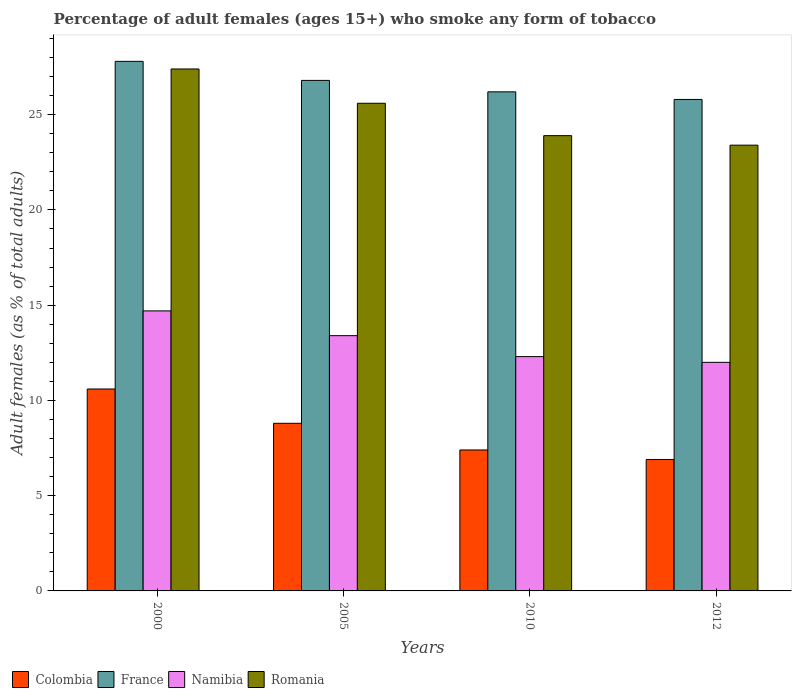How many groups of bars are there?
Offer a terse response. 4. What is the label of the 1st group of bars from the left?
Give a very brief answer. 2000. In how many cases, is the number of bars for a given year not equal to the number of legend labels?
Ensure brevity in your answer.  0. What is the percentage of adult females who smoke in France in 2012?
Provide a succinct answer. 25.8. Across all years, what is the maximum percentage of adult females who smoke in France?
Your answer should be compact. 27.8. Across all years, what is the minimum percentage of adult females who smoke in Romania?
Offer a very short reply. 23.4. In which year was the percentage of adult females who smoke in France minimum?
Your response must be concise. 2012. What is the total percentage of adult females who smoke in Colombia in the graph?
Provide a succinct answer. 33.7. What is the difference between the percentage of adult females who smoke in Namibia in 2000 and that in 2012?
Provide a short and direct response. 2.7. What is the difference between the percentage of adult females who smoke in Namibia in 2010 and the percentage of adult females who smoke in France in 2012?
Provide a short and direct response. -13.5. What is the average percentage of adult females who smoke in France per year?
Offer a very short reply. 26.65. In the year 2000, what is the difference between the percentage of adult females who smoke in France and percentage of adult females who smoke in Romania?
Provide a succinct answer. 0.4. What is the ratio of the percentage of adult females who smoke in Romania in 2005 to that in 2012?
Keep it short and to the point. 1.09. What is the difference between the highest and the second highest percentage of adult females who smoke in Romania?
Make the answer very short. 1.8. What is the difference between the highest and the lowest percentage of adult females who smoke in Romania?
Make the answer very short. 4. Is the sum of the percentage of adult females who smoke in Colombia in 2005 and 2010 greater than the maximum percentage of adult females who smoke in Romania across all years?
Ensure brevity in your answer.  No. What does the 4th bar from the left in 2000 represents?
Provide a succinct answer. Romania. Is it the case that in every year, the sum of the percentage of adult females who smoke in Romania and percentage of adult females who smoke in Namibia is greater than the percentage of adult females who smoke in France?
Offer a terse response. Yes. How many bars are there?
Give a very brief answer. 16. How many years are there in the graph?
Your answer should be very brief. 4. What is the difference between two consecutive major ticks on the Y-axis?
Provide a short and direct response. 5. Are the values on the major ticks of Y-axis written in scientific E-notation?
Provide a succinct answer. No. How many legend labels are there?
Provide a succinct answer. 4. What is the title of the graph?
Keep it short and to the point. Percentage of adult females (ages 15+) who smoke any form of tobacco. What is the label or title of the Y-axis?
Provide a succinct answer. Adult females (as % of total adults). What is the Adult females (as % of total adults) of France in 2000?
Give a very brief answer. 27.8. What is the Adult females (as % of total adults) of Romania in 2000?
Your response must be concise. 27.4. What is the Adult females (as % of total adults) of France in 2005?
Keep it short and to the point. 26.8. What is the Adult females (as % of total adults) of Romania in 2005?
Your answer should be very brief. 25.6. What is the Adult females (as % of total adults) of Colombia in 2010?
Your answer should be very brief. 7.4. What is the Adult females (as % of total adults) in France in 2010?
Your answer should be compact. 26.2. What is the Adult females (as % of total adults) in Namibia in 2010?
Give a very brief answer. 12.3. What is the Adult females (as % of total adults) in Romania in 2010?
Provide a succinct answer. 23.9. What is the Adult females (as % of total adults) of Colombia in 2012?
Your answer should be very brief. 6.9. What is the Adult females (as % of total adults) in France in 2012?
Your answer should be very brief. 25.8. What is the Adult females (as % of total adults) in Romania in 2012?
Offer a terse response. 23.4. Across all years, what is the maximum Adult females (as % of total adults) in France?
Offer a very short reply. 27.8. Across all years, what is the maximum Adult females (as % of total adults) of Namibia?
Your answer should be compact. 14.7. Across all years, what is the maximum Adult females (as % of total adults) of Romania?
Your answer should be compact. 27.4. Across all years, what is the minimum Adult females (as % of total adults) in Colombia?
Provide a short and direct response. 6.9. Across all years, what is the minimum Adult females (as % of total adults) of France?
Give a very brief answer. 25.8. Across all years, what is the minimum Adult females (as % of total adults) of Namibia?
Give a very brief answer. 12. Across all years, what is the minimum Adult females (as % of total adults) in Romania?
Keep it short and to the point. 23.4. What is the total Adult females (as % of total adults) in Colombia in the graph?
Provide a short and direct response. 33.7. What is the total Adult females (as % of total adults) in France in the graph?
Your response must be concise. 106.6. What is the total Adult females (as % of total adults) of Namibia in the graph?
Your answer should be very brief. 52.4. What is the total Adult females (as % of total adults) in Romania in the graph?
Give a very brief answer. 100.3. What is the difference between the Adult females (as % of total adults) of Colombia in 2000 and that in 2005?
Ensure brevity in your answer.  1.8. What is the difference between the Adult females (as % of total adults) of France in 2000 and that in 2005?
Your answer should be very brief. 1. What is the difference between the Adult females (as % of total adults) of Colombia in 2000 and that in 2010?
Make the answer very short. 3.2. What is the difference between the Adult females (as % of total adults) of Namibia in 2000 and that in 2010?
Ensure brevity in your answer.  2.4. What is the difference between the Adult females (as % of total adults) of Romania in 2000 and that in 2012?
Give a very brief answer. 4. What is the difference between the Adult females (as % of total adults) of Colombia in 2005 and that in 2010?
Make the answer very short. 1.4. What is the difference between the Adult females (as % of total adults) of France in 2005 and that in 2010?
Ensure brevity in your answer.  0.6. What is the difference between the Adult females (as % of total adults) of Namibia in 2005 and that in 2010?
Ensure brevity in your answer.  1.1. What is the difference between the Adult females (as % of total adults) of Romania in 2005 and that in 2010?
Offer a very short reply. 1.7. What is the difference between the Adult females (as % of total adults) in Namibia in 2005 and that in 2012?
Your answer should be very brief. 1.4. What is the difference between the Adult females (as % of total adults) of France in 2010 and that in 2012?
Make the answer very short. 0.4. What is the difference between the Adult females (as % of total adults) in Romania in 2010 and that in 2012?
Make the answer very short. 0.5. What is the difference between the Adult females (as % of total adults) of Colombia in 2000 and the Adult females (as % of total adults) of France in 2005?
Give a very brief answer. -16.2. What is the difference between the Adult females (as % of total adults) in Colombia in 2000 and the Adult females (as % of total adults) in Namibia in 2005?
Keep it short and to the point. -2.8. What is the difference between the Adult females (as % of total adults) of Colombia in 2000 and the Adult females (as % of total adults) of Romania in 2005?
Ensure brevity in your answer.  -15. What is the difference between the Adult females (as % of total adults) of France in 2000 and the Adult females (as % of total adults) of Namibia in 2005?
Your answer should be compact. 14.4. What is the difference between the Adult females (as % of total adults) of France in 2000 and the Adult females (as % of total adults) of Romania in 2005?
Provide a succinct answer. 2.2. What is the difference between the Adult females (as % of total adults) of Colombia in 2000 and the Adult females (as % of total adults) of France in 2010?
Ensure brevity in your answer.  -15.6. What is the difference between the Adult females (as % of total adults) in Colombia in 2000 and the Adult females (as % of total adults) in Romania in 2010?
Ensure brevity in your answer.  -13.3. What is the difference between the Adult females (as % of total adults) in France in 2000 and the Adult females (as % of total adults) in Romania in 2010?
Your answer should be compact. 3.9. What is the difference between the Adult females (as % of total adults) in Namibia in 2000 and the Adult females (as % of total adults) in Romania in 2010?
Offer a very short reply. -9.2. What is the difference between the Adult females (as % of total adults) in Colombia in 2000 and the Adult females (as % of total adults) in France in 2012?
Your response must be concise. -15.2. What is the difference between the Adult females (as % of total adults) of Colombia in 2000 and the Adult females (as % of total adults) of Romania in 2012?
Offer a terse response. -12.8. What is the difference between the Adult females (as % of total adults) of Namibia in 2000 and the Adult females (as % of total adults) of Romania in 2012?
Your answer should be very brief. -8.7. What is the difference between the Adult females (as % of total adults) of Colombia in 2005 and the Adult females (as % of total adults) of France in 2010?
Your response must be concise. -17.4. What is the difference between the Adult females (as % of total adults) in Colombia in 2005 and the Adult females (as % of total adults) in Romania in 2010?
Offer a terse response. -15.1. What is the difference between the Adult females (as % of total adults) in France in 2005 and the Adult females (as % of total adults) in Namibia in 2010?
Provide a succinct answer. 14.5. What is the difference between the Adult females (as % of total adults) of Colombia in 2005 and the Adult females (as % of total adults) of France in 2012?
Keep it short and to the point. -17. What is the difference between the Adult females (as % of total adults) of Colombia in 2005 and the Adult females (as % of total adults) of Namibia in 2012?
Offer a terse response. -3.2. What is the difference between the Adult females (as % of total adults) of Colombia in 2005 and the Adult females (as % of total adults) of Romania in 2012?
Your answer should be very brief. -14.6. What is the difference between the Adult females (as % of total adults) in Namibia in 2005 and the Adult females (as % of total adults) in Romania in 2012?
Keep it short and to the point. -10. What is the difference between the Adult females (as % of total adults) of Colombia in 2010 and the Adult females (as % of total adults) of France in 2012?
Offer a terse response. -18.4. What is the difference between the Adult females (as % of total adults) in Colombia in 2010 and the Adult females (as % of total adults) in Namibia in 2012?
Your response must be concise. -4.6. What is the difference between the Adult females (as % of total adults) in France in 2010 and the Adult females (as % of total adults) in Namibia in 2012?
Offer a terse response. 14.2. What is the average Adult females (as % of total adults) of Colombia per year?
Your response must be concise. 8.43. What is the average Adult females (as % of total adults) in France per year?
Your answer should be very brief. 26.65. What is the average Adult females (as % of total adults) in Namibia per year?
Offer a terse response. 13.1. What is the average Adult females (as % of total adults) of Romania per year?
Provide a short and direct response. 25.07. In the year 2000, what is the difference between the Adult females (as % of total adults) of Colombia and Adult females (as % of total adults) of France?
Make the answer very short. -17.2. In the year 2000, what is the difference between the Adult females (as % of total adults) of Colombia and Adult females (as % of total adults) of Romania?
Provide a short and direct response. -16.8. In the year 2000, what is the difference between the Adult females (as % of total adults) in France and Adult females (as % of total adults) in Romania?
Keep it short and to the point. 0.4. In the year 2000, what is the difference between the Adult females (as % of total adults) of Namibia and Adult females (as % of total adults) of Romania?
Your answer should be compact. -12.7. In the year 2005, what is the difference between the Adult females (as % of total adults) in Colombia and Adult females (as % of total adults) in Namibia?
Provide a short and direct response. -4.6. In the year 2005, what is the difference between the Adult females (as % of total adults) of Colombia and Adult females (as % of total adults) of Romania?
Offer a terse response. -16.8. In the year 2005, what is the difference between the Adult females (as % of total adults) in France and Adult females (as % of total adults) in Romania?
Offer a very short reply. 1.2. In the year 2010, what is the difference between the Adult females (as % of total adults) of Colombia and Adult females (as % of total adults) of France?
Make the answer very short. -18.8. In the year 2010, what is the difference between the Adult females (as % of total adults) in Colombia and Adult females (as % of total adults) in Namibia?
Offer a terse response. -4.9. In the year 2010, what is the difference between the Adult females (as % of total adults) of Colombia and Adult females (as % of total adults) of Romania?
Your answer should be compact. -16.5. In the year 2010, what is the difference between the Adult females (as % of total adults) in Namibia and Adult females (as % of total adults) in Romania?
Provide a succinct answer. -11.6. In the year 2012, what is the difference between the Adult females (as % of total adults) in Colombia and Adult females (as % of total adults) in France?
Provide a short and direct response. -18.9. In the year 2012, what is the difference between the Adult females (as % of total adults) in Colombia and Adult females (as % of total adults) in Romania?
Your answer should be very brief. -16.5. In the year 2012, what is the difference between the Adult females (as % of total adults) of France and Adult females (as % of total adults) of Romania?
Make the answer very short. 2.4. In the year 2012, what is the difference between the Adult females (as % of total adults) in Namibia and Adult females (as % of total adults) in Romania?
Your answer should be compact. -11.4. What is the ratio of the Adult females (as % of total adults) of Colombia in 2000 to that in 2005?
Your answer should be compact. 1.2. What is the ratio of the Adult females (as % of total adults) of France in 2000 to that in 2005?
Provide a succinct answer. 1.04. What is the ratio of the Adult females (as % of total adults) in Namibia in 2000 to that in 2005?
Provide a succinct answer. 1.1. What is the ratio of the Adult females (as % of total adults) in Romania in 2000 to that in 2005?
Provide a succinct answer. 1.07. What is the ratio of the Adult females (as % of total adults) in Colombia in 2000 to that in 2010?
Keep it short and to the point. 1.43. What is the ratio of the Adult females (as % of total adults) in France in 2000 to that in 2010?
Ensure brevity in your answer.  1.06. What is the ratio of the Adult females (as % of total adults) in Namibia in 2000 to that in 2010?
Provide a short and direct response. 1.2. What is the ratio of the Adult females (as % of total adults) in Romania in 2000 to that in 2010?
Your answer should be very brief. 1.15. What is the ratio of the Adult females (as % of total adults) of Colombia in 2000 to that in 2012?
Your answer should be very brief. 1.54. What is the ratio of the Adult females (as % of total adults) in France in 2000 to that in 2012?
Ensure brevity in your answer.  1.08. What is the ratio of the Adult females (as % of total adults) in Namibia in 2000 to that in 2012?
Provide a short and direct response. 1.23. What is the ratio of the Adult females (as % of total adults) of Romania in 2000 to that in 2012?
Give a very brief answer. 1.17. What is the ratio of the Adult females (as % of total adults) of Colombia in 2005 to that in 2010?
Ensure brevity in your answer.  1.19. What is the ratio of the Adult females (as % of total adults) of France in 2005 to that in 2010?
Offer a terse response. 1.02. What is the ratio of the Adult females (as % of total adults) of Namibia in 2005 to that in 2010?
Keep it short and to the point. 1.09. What is the ratio of the Adult females (as % of total adults) in Romania in 2005 to that in 2010?
Make the answer very short. 1.07. What is the ratio of the Adult females (as % of total adults) of Colombia in 2005 to that in 2012?
Provide a succinct answer. 1.28. What is the ratio of the Adult females (as % of total adults) in France in 2005 to that in 2012?
Provide a short and direct response. 1.04. What is the ratio of the Adult females (as % of total adults) in Namibia in 2005 to that in 2012?
Make the answer very short. 1.12. What is the ratio of the Adult females (as % of total adults) of Romania in 2005 to that in 2012?
Keep it short and to the point. 1.09. What is the ratio of the Adult females (as % of total adults) of Colombia in 2010 to that in 2012?
Give a very brief answer. 1.07. What is the ratio of the Adult females (as % of total adults) of France in 2010 to that in 2012?
Your answer should be very brief. 1.02. What is the ratio of the Adult females (as % of total adults) in Romania in 2010 to that in 2012?
Give a very brief answer. 1.02. What is the difference between the highest and the second highest Adult females (as % of total adults) in Colombia?
Keep it short and to the point. 1.8. What is the difference between the highest and the second highest Adult females (as % of total adults) of France?
Ensure brevity in your answer.  1. What is the difference between the highest and the second highest Adult females (as % of total adults) in Namibia?
Ensure brevity in your answer.  1.3. What is the difference between the highest and the lowest Adult females (as % of total adults) in Colombia?
Your answer should be very brief. 3.7. What is the difference between the highest and the lowest Adult females (as % of total adults) of France?
Offer a terse response. 2. What is the difference between the highest and the lowest Adult females (as % of total adults) in Romania?
Offer a very short reply. 4. 